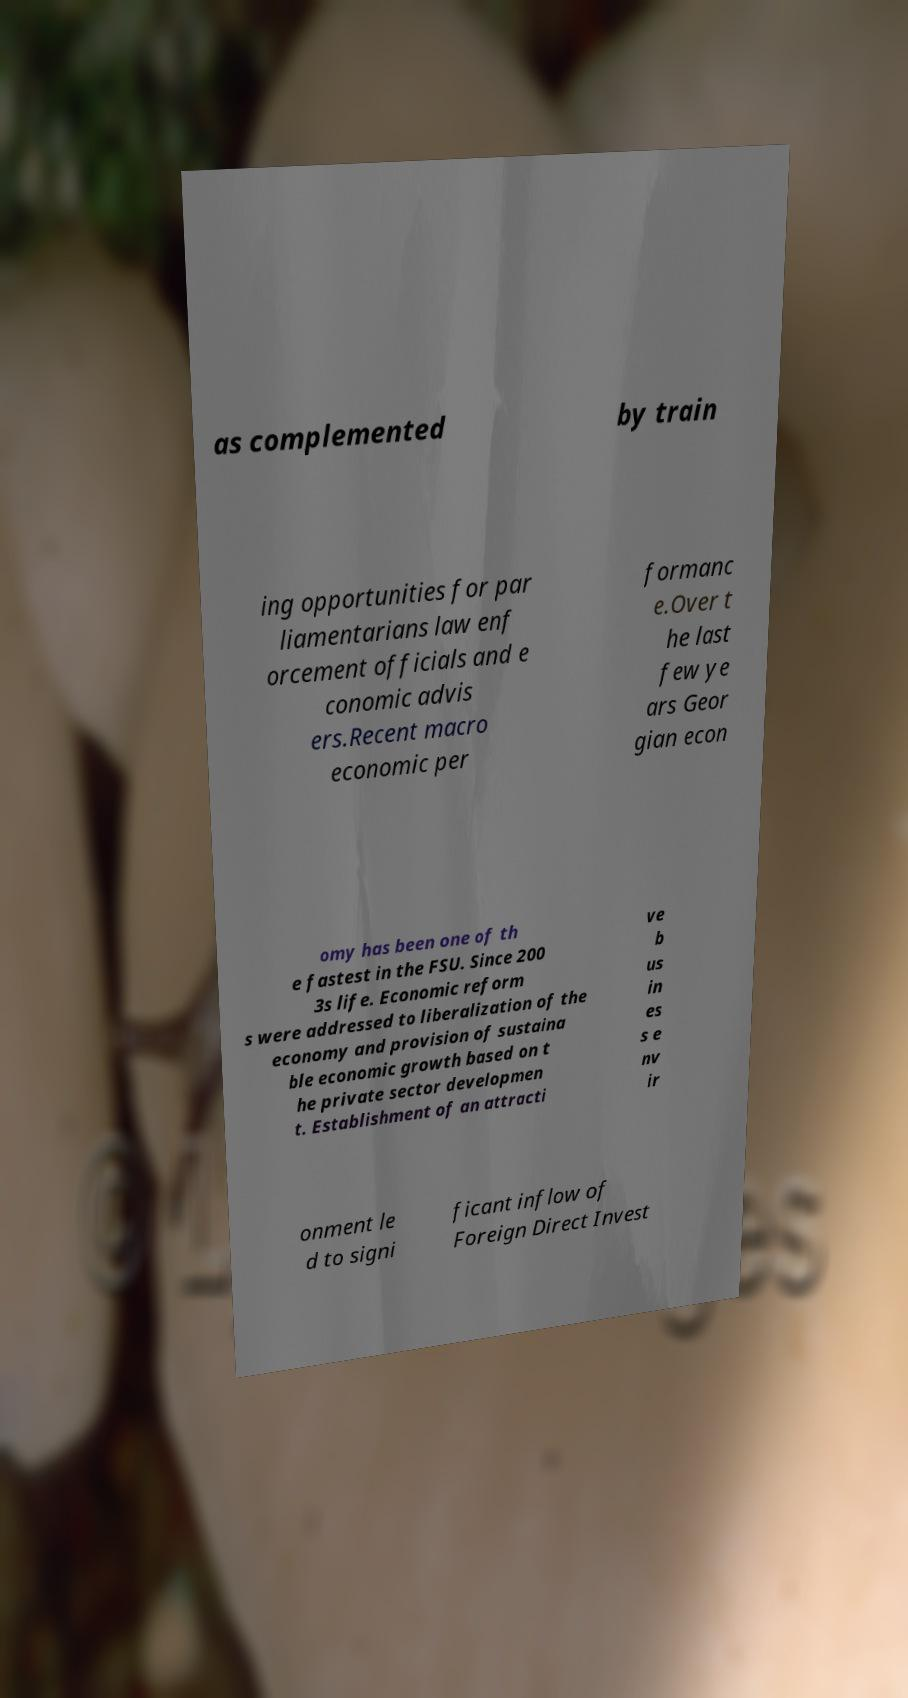Please identify and transcribe the text found in this image. as complemented by train ing opportunities for par liamentarians law enf orcement officials and e conomic advis ers.Recent macro economic per formanc e.Over t he last few ye ars Geor gian econ omy has been one of th e fastest in the FSU. Since 200 3s life. Economic reform s were addressed to liberalization of the economy and provision of sustaina ble economic growth based on t he private sector developmen t. Establishment of an attracti ve b us in es s e nv ir onment le d to signi ficant inflow of Foreign Direct Invest 